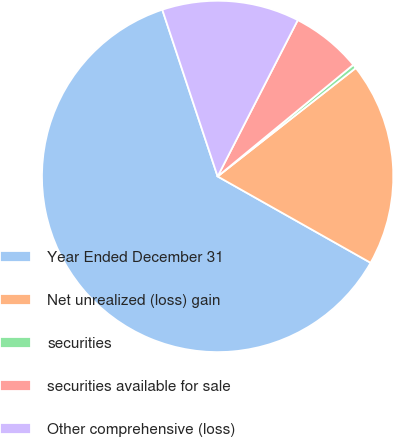Convert chart. <chart><loc_0><loc_0><loc_500><loc_500><pie_chart><fcel>Year Ended December 31<fcel>Net unrealized (loss) gain<fcel>securities<fcel>securities available for sale<fcel>Other comprehensive (loss)<nl><fcel>61.72%<fcel>18.77%<fcel>0.37%<fcel>6.5%<fcel>12.64%<nl></chart> 